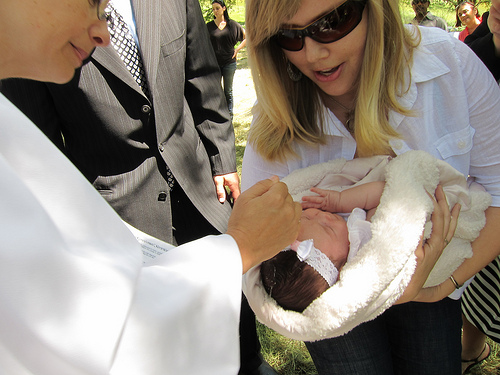<image>
Is the women to the left of the man? No. The women is not to the left of the man. From this viewpoint, they have a different horizontal relationship. 